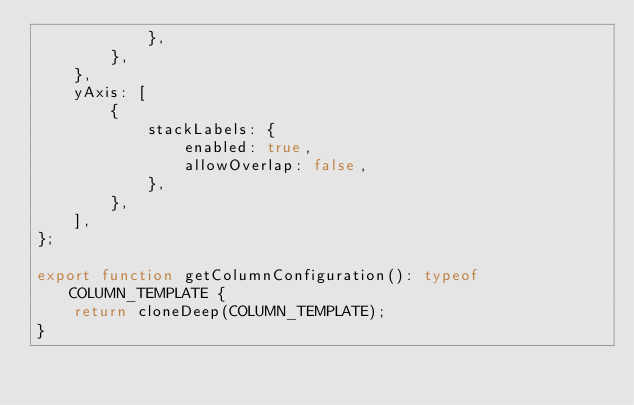Convert code to text. <code><loc_0><loc_0><loc_500><loc_500><_TypeScript_>            },
        },
    },
    yAxis: [
        {
            stackLabels: {
                enabled: true,
                allowOverlap: false,
            },
        },
    ],
};

export function getColumnConfiguration(): typeof COLUMN_TEMPLATE {
    return cloneDeep(COLUMN_TEMPLATE);
}
</code> 